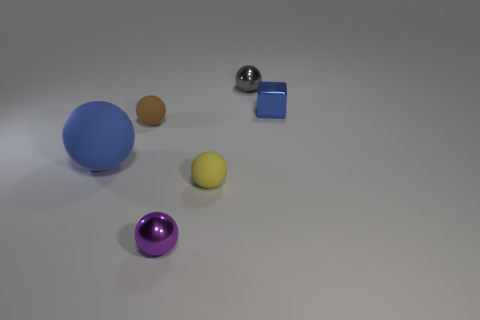Are there any other things that are the same size as the blue matte sphere?
Your response must be concise. No. Is the blue ball the same size as the cube?
Make the answer very short. No. What is the purple ball made of?
Your response must be concise. Metal. There is a tiny ball that is made of the same material as the yellow thing; what color is it?
Keep it short and to the point. Brown. Are the purple ball and the block that is right of the small purple shiny object made of the same material?
Keep it short and to the point. Yes. How many small gray spheres have the same material as the brown ball?
Offer a terse response. 0. There is a tiny metal object that is in front of the small blue thing; what shape is it?
Make the answer very short. Sphere. Are the blue object right of the small yellow matte thing and the tiny gray thing that is on the right side of the purple metallic ball made of the same material?
Your answer should be compact. Yes. Are there any other big matte objects of the same shape as the large blue object?
Your answer should be compact. No. What number of objects are either rubber spheres that are on the left side of the tiny brown ball or small things?
Offer a very short reply. 6. 